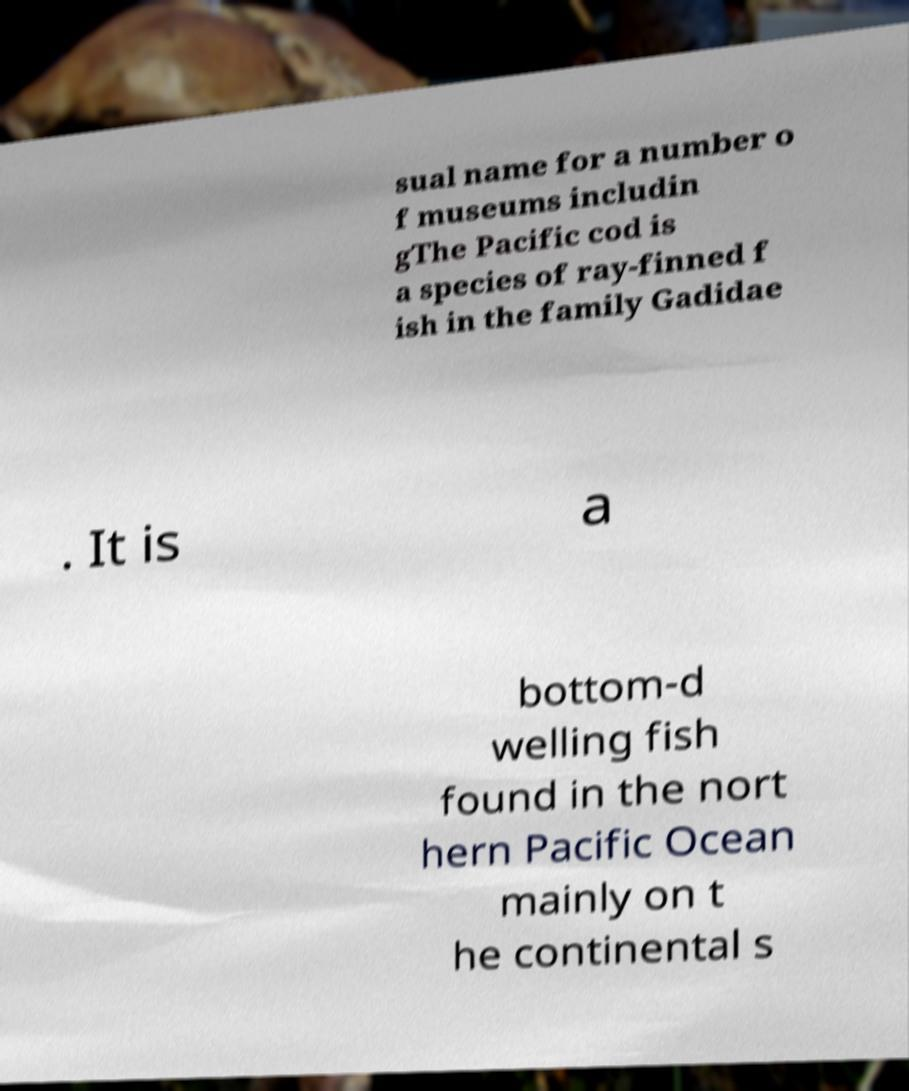What messages or text are displayed in this image? I need them in a readable, typed format. sual name for a number o f museums includin gThe Pacific cod is a species of ray-finned f ish in the family Gadidae . It is a bottom-d welling fish found in the nort hern Pacific Ocean mainly on t he continental s 